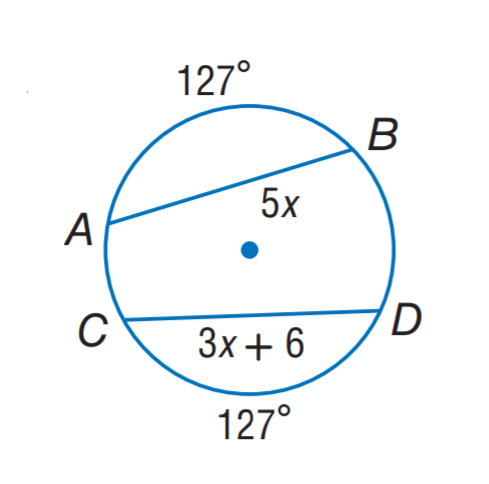Question: Find x.
Choices:
A. 3
B. 4
C. 5
D. 6
Answer with the letter. Answer: A 